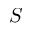<formula> <loc_0><loc_0><loc_500><loc_500>S</formula> 